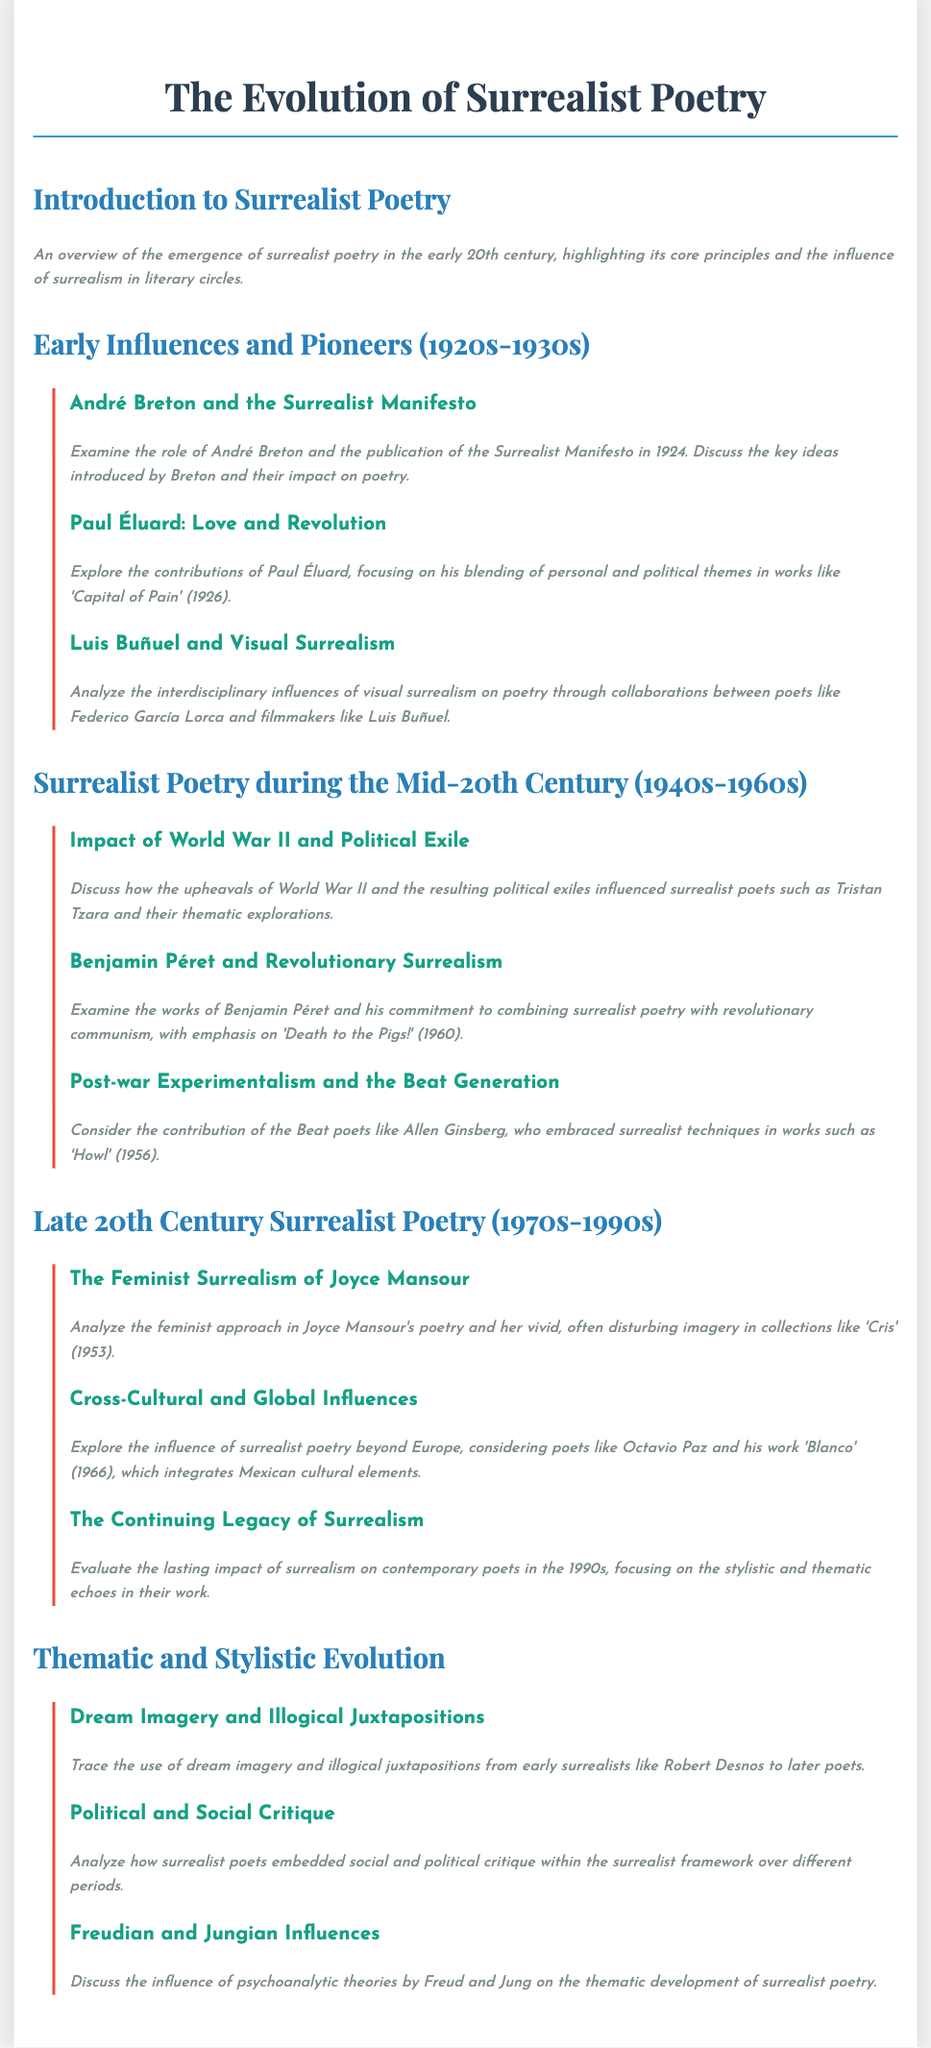What year was the Surrealist Manifesto published? The Surrealist Manifesto was published in 1924.
Answer: 1924 Who is known for blending personal and political themes in 'Capital of Pain'? Paul Éluard is known for this blending in his work 'Capital of Pain'.
Answer: Paul Éluard Which poet is associated with the work 'Death to the Pigs!'? Benjamin Péret is associated with the work 'Death to the Pigs!'.
Answer: Benjamin Péret What significant historical event affected surrealist poets in the mid-20th century? World War II significantly affected surrealist poets during this time.
Answer: World War II In which collection did Joyce Mansour explore feminist surrealism? Joyce Mansour explored feminist surrealism in her collection 'Cris'.
Answer: 'Cris' Which poet integrated Mexican cultural elements in his work 'Blanco'? Octavio Paz integrated Mexican cultural elements in his work 'Blanco'.
Answer: Octavio Paz How did surrealist poets incorporate social critique? Surrealist poets embedded social critique within the surrealist framework over different periods.
Answer: Through the surrealist framework What psychological theories influenced the thematic development of surrealist poetry? Freudian and Jungian theories influenced the thematic development of surrealist poetry.
Answer: Freudian and Jungian What is a common stylistic feature of early surrealist poetry? A common stylistic feature is the use of dream imagery and illogical juxtapositions.
Answer: Dream imagery and illogical juxtapositions 